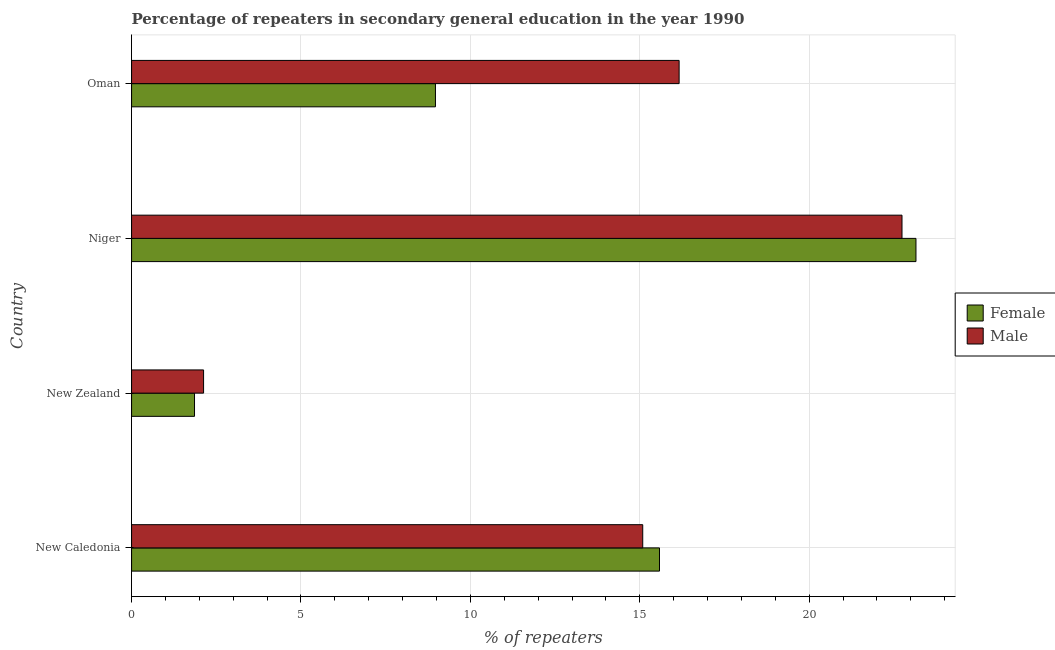How many different coloured bars are there?
Offer a terse response. 2. Are the number of bars per tick equal to the number of legend labels?
Make the answer very short. Yes. How many bars are there on the 3rd tick from the bottom?
Give a very brief answer. 2. What is the label of the 2nd group of bars from the top?
Offer a terse response. Niger. In how many cases, is the number of bars for a given country not equal to the number of legend labels?
Make the answer very short. 0. What is the percentage of male repeaters in Oman?
Your answer should be very brief. 16.16. Across all countries, what is the maximum percentage of male repeaters?
Keep it short and to the point. 22.74. Across all countries, what is the minimum percentage of female repeaters?
Ensure brevity in your answer.  1.86. In which country was the percentage of female repeaters maximum?
Your answer should be very brief. Niger. In which country was the percentage of male repeaters minimum?
Your answer should be very brief. New Zealand. What is the total percentage of male repeaters in the graph?
Your response must be concise. 56.12. What is the difference between the percentage of female repeaters in New Zealand and that in Oman?
Provide a succinct answer. -7.11. What is the difference between the percentage of female repeaters in New Caledonia and the percentage of male repeaters in Oman?
Your answer should be compact. -0.58. What is the average percentage of male repeaters per country?
Keep it short and to the point. 14.03. What is the difference between the percentage of male repeaters and percentage of female repeaters in New Zealand?
Provide a short and direct response. 0.27. In how many countries, is the percentage of female repeaters greater than 4 %?
Give a very brief answer. 3. What is the ratio of the percentage of male repeaters in New Caledonia to that in Niger?
Make the answer very short. 0.66. Is the percentage of male repeaters in New Caledonia less than that in Niger?
Give a very brief answer. Yes. What is the difference between the highest and the second highest percentage of male repeaters?
Keep it short and to the point. 6.58. What is the difference between the highest and the lowest percentage of female repeaters?
Offer a very short reply. 21.3. Is the sum of the percentage of female repeaters in New Caledonia and Oman greater than the maximum percentage of male repeaters across all countries?
Your answer should be very brief. Yes. What does the 2nd bar from the top in New Caledonia represents?
Your answer should be very brief. Female. What does the 1st bar from the bottom in New Caledonia represents?
Ensure brevity in your answer.  Female. How many bars are there?
Offer a very short reply. 8. Where does the legend appear in the graph?
Offer a very short reply. Center right. How are the legend labels stacked?
Give a very brief answer. Vertical. What is the title of the graph?
Your answer should be very brief. Percentage of repeaters in secondary general education in the year 1990. Does "Under-5(female)" appear as one of the legend labels in the graph?
Give a very brief answer. No. What is the label or title of the X-axis?
Your answer should be compact. % of repeaters. What is the label or title of the Y-axis?
Offer a very short reply. Country. What is the % of repeaters of Female in New Caledonia?
Your answer should be compact. 15.58. What is the % of repeaters of Male in New Caledonia?
Provide a short and direct response. 15.09. What is the % of repeaters in Female in New Zealand?
Keep it short and to the point. 1.86. What is the % of repeaters of Male in New Zealand?
Your answer should be very brief. 2.13. What is the % of repeaters of Female in Niger?
Ensure brevity in your answer.  23.15. What is the % of repeaters in Male in Niger?
Make the answer very short. 22.74. What is the % of repeaters of Female in Oman?
Provide a succinct answer. 8.97. What is the % of repeaters of Male in Oman?
Your answer should be compact. 16.16. Across all countries, what is the maximum % of repeaters of Female?
Keep it short and to the point. 23.15. Across all countries, what is the maximum % of repeaters in Male?
Keep it short and to the point. 22.74. Across all countries, what is the minimum % of repeaters of Female?
Your answer should be very brief. 1.86. Across all countries, what is the minimum % of repeaters in Male?
Your answer should be compact. 2.13. What is the total % of repeaters of Female in the graph?
Offer a very short reply. 49.56. What is the total % of repeaters in Male in the graph?
Offer a very short reply. 56.12. What is the difference between the % of repeaters of Female in New Caledonia and that in New Zealand?
Offer a very short reply. 13.72. What is the difference between the % of repeaters of Male in New Caledonia and that in New Zealand?
Offer a very short reply. 12.96. What is the difference between the % of repeaters in Female in New Caledonia and that in Niger?
Provide a succinct answer. -7.57. What is the difference between the % of repeaters of Male in New Caledonia and that in Niger?
Keep it short and to the point. -7.65. What is the difference between the % of repeaters in Female in New Caledonia and that in Oman?
Ensure brevity in your answer.  6.61. What is the difference between the % of repeaters of Male in New Caledonia and that in Oman?
Offer a terse response. -1.07. What is the difference between the % of repeaters of Female in New Zealand and that in Niger?
Provide a short and direct response. -21.3. What is the difference between the % of repeaters in Male in New Zealand and that in Niger?
Keep it short and to the point. -20.62. What is the difference between the % of repeaters of Female in New Zealand and that in Oman?
Your answer should be very brief. -7.11. What is the difference between the % of repeaters of Male in New Zealand and that in Oman?
Ensure brevity in your answer.  -14.04. What is the difference between the % of repeaters in Female in Niger and that in Oman?
Provide a short and direct response. 14.18. What is the difference between the % of repeaters in Male in Niger and that in Oman?
Keep it short and to the point. 6.58. What is the difference between the % of repeaters of Female in New Caledonia and the % of repeaters of Male in New Zealand?
Your answer should be very brief. 13.46. What is the difference between the % of repeaters in Female in New Caledonia and the % of repeaters in Male in Niger?
Give a very brief answer. -7.16. What is the difference between the % of repeaters in Female in New Caledonia and the % of repeaters in Male in Oman?
Ensure brevity in your answer.  -0.58. What is the difference between the % of repeaters of Female in New Zealand and the % of repeaters of Male in Niger?
Your response must be concise. -20.88. What is the difference between the % of repeaters of Female in New Zealand and the % of repeaters of Male in Oman?
Offer a terse response. -14.3. What is the difference between the % of repeaters in Female in Niger and the % of repeaters in Male in Oman?
Keep it short and to the point. 6.99. What is the average % of repeaters of Female per country?
Offer a very short reply. 12.39. What is the average % of repeaters in Male per country?
Make the answer very short. 14.03. What is the difference between the % of repeaters in Female and % of repeaters in Male in New Caledonia?
Your answer should be very brief. 0.49. What is the difference between the % of repeaters in Female and % of repeaters in Male in New Zealand?
Ensure brevity in your answer.  -0.27. What is the difference between the % of repeaters of Female and % of repeaters of Male in Niger?
Your answer should be very brief. 0.41. What is the difference between the % of repeaters in Female and % of repeaters in Male in Oman?
Your answer should be compact. -7.19. What is the ratio of the % of repeaters in Female in New Caledonia to that in New Zealand?
Provide a short and direct response. 8.39. What is the ratio of the % of repeaters of Male in New Caledonia to that in New Zealand?
Provide a short and direct response. 7.1. What is the ratio of the % of repeaters of Female in New Caledonia to that in Niger?
Keep it short and to the point. 0.67. What is the ratio of the % of repeaters in Male in New Caledonia to that in Niger?
Provide a short and direct response. 0.66. What is the ratio of the % of repeaters of Female in New Caledonia to that in Oman?
Offer a terse response. 1.74. What is the ratio of the % of repeaters in Male in New Caledonia to that in Oman?
Offer a terse response. 0.93. What is the ratio of the % of repeaters in Female in New Zealand to that in Niger?
Provide a short and direct response. 0.08. What is the ratio of the % of repeaters of Male in New Zealand to that in Niger?
Ensure brevity in your answer.  0.09. What is the ratio of the % of repeaters in Female in New Zealand to that in Oman?
Make the answer very short. 0.21. What is the ratio of the % of repeaters of Male in New Zealand to that in Oman?
Offer a terse response. 0.13. What is the ratio of the % of repeaters of Female in Niger to that in Oman?
Your answer should be very brief. 2.58. What is the ratio of the % of repeaters of Male in Niger to that in Oman?
Offer a very short reply. 1.41. What is the difference between the highest and the second highest % of repeaters of Female?
Make the answer very short. 7.57. What is the difference between the highest and the second highest % of repeaters of Male?
Make the answer very short. 6.58. What is the difference between the highest and the lowest % of repeaters of Female?
Your answer should be very brief. 21.3. What is the difference between the highest and the lowest % of repeaters of Male?
Your answer should be compact. 20.62. 